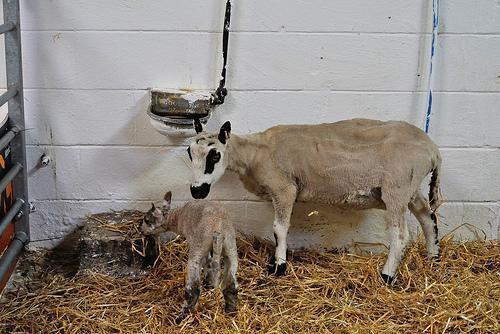How many black donkey are there?
Give a very brief answer. 0. How many small animals are in the picture?
Give a very brief answer. 1. 